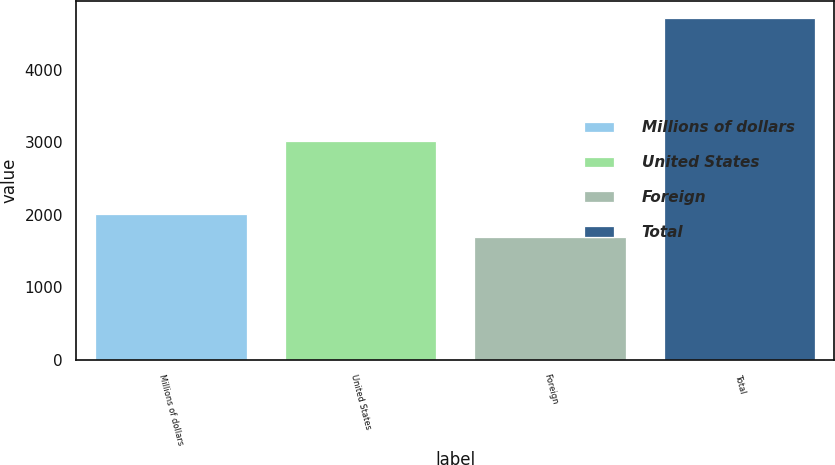<chart> <loc_0><loc_0><loc_500><loc_500><bar_chart><fcel>Millions of dollars<fcel>United States<fcel>Foreign<fcel>Total<nl><fcel>2014<fcel>3020<fcel>1692<fcel>4712<nl></chart> 